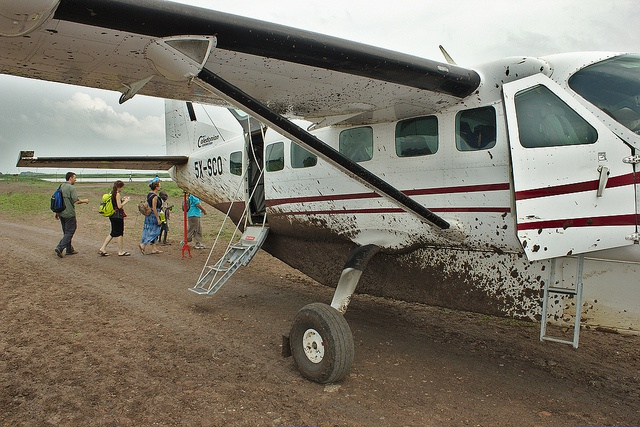Describe the objects in this image and their specific colors. I can see airplane in gray, black, darkgray, and lightgray tones, people in gray and black tones, people in gray, black, tan, and maroon tones, people in gray, black, and blue tones, and people in gray, teal, and maroon tones in this image. 